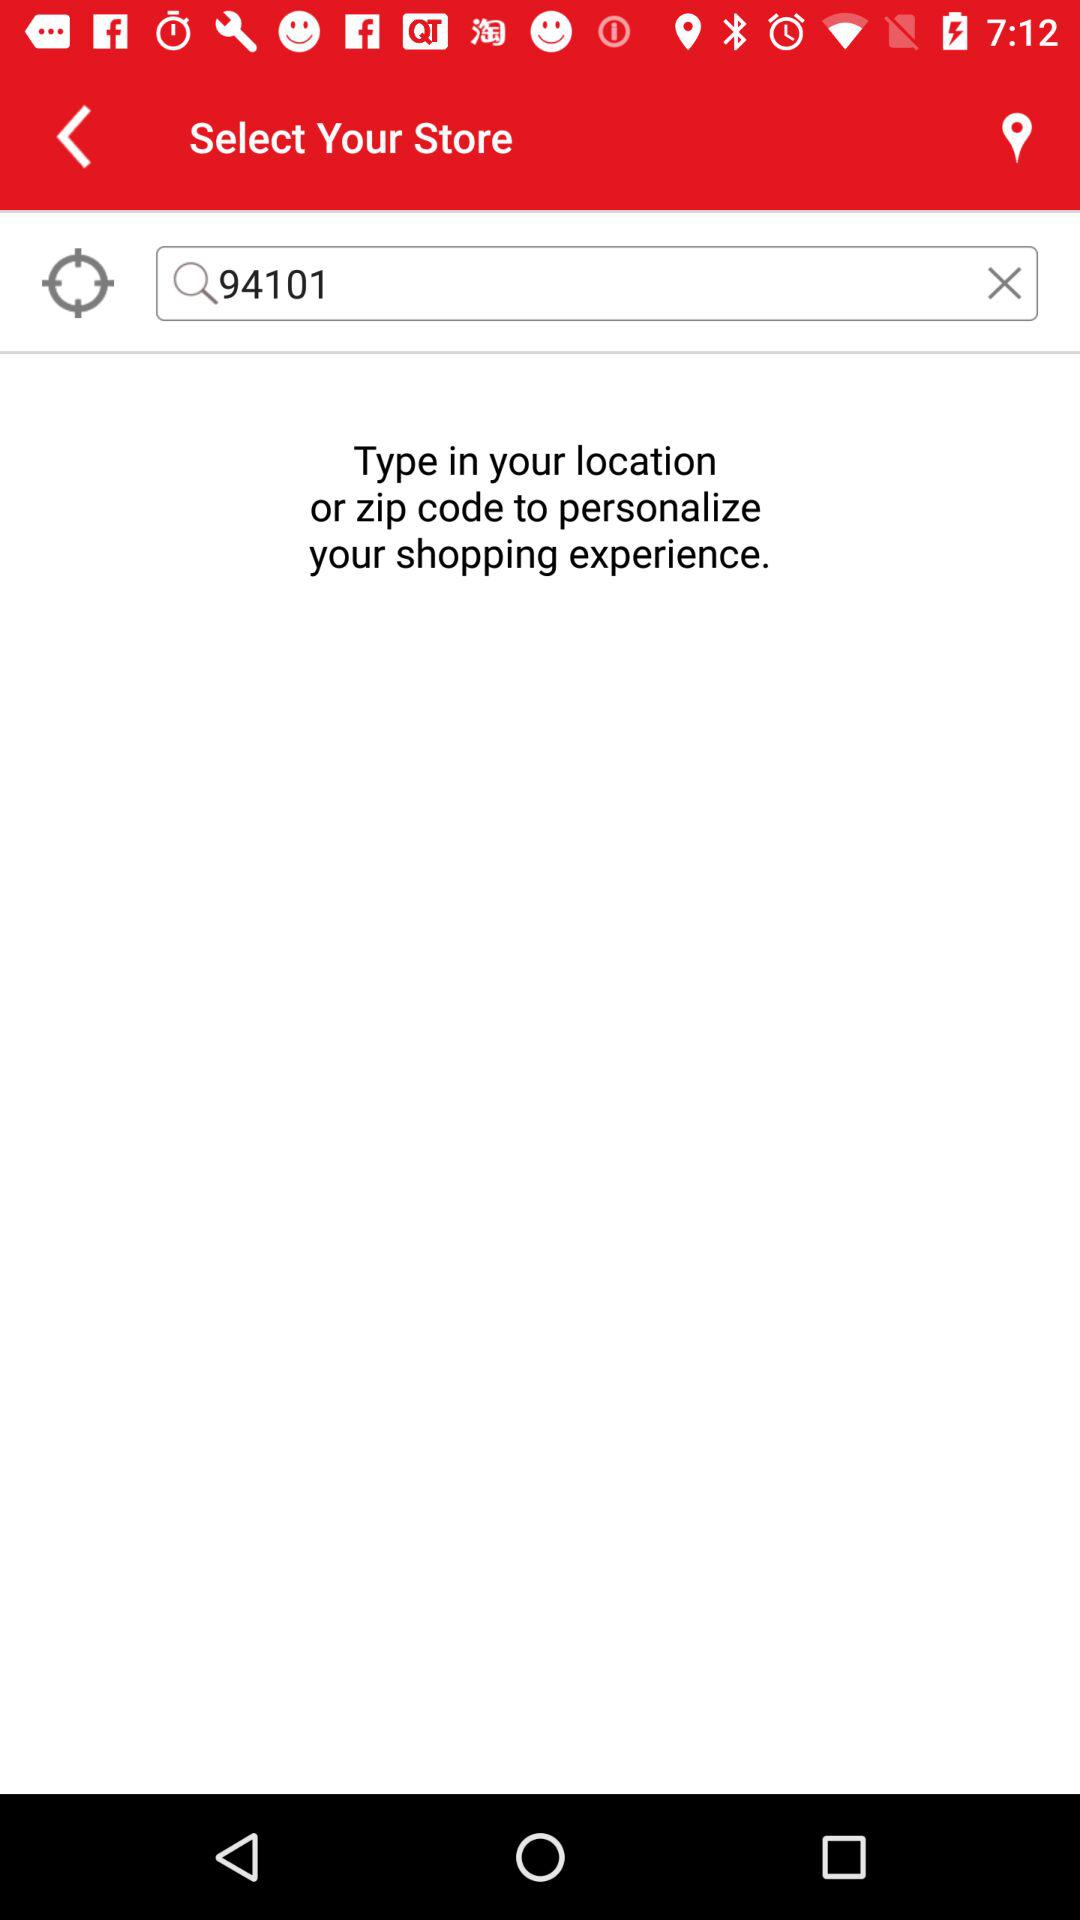What is the zip code? The zip code is 94101. 